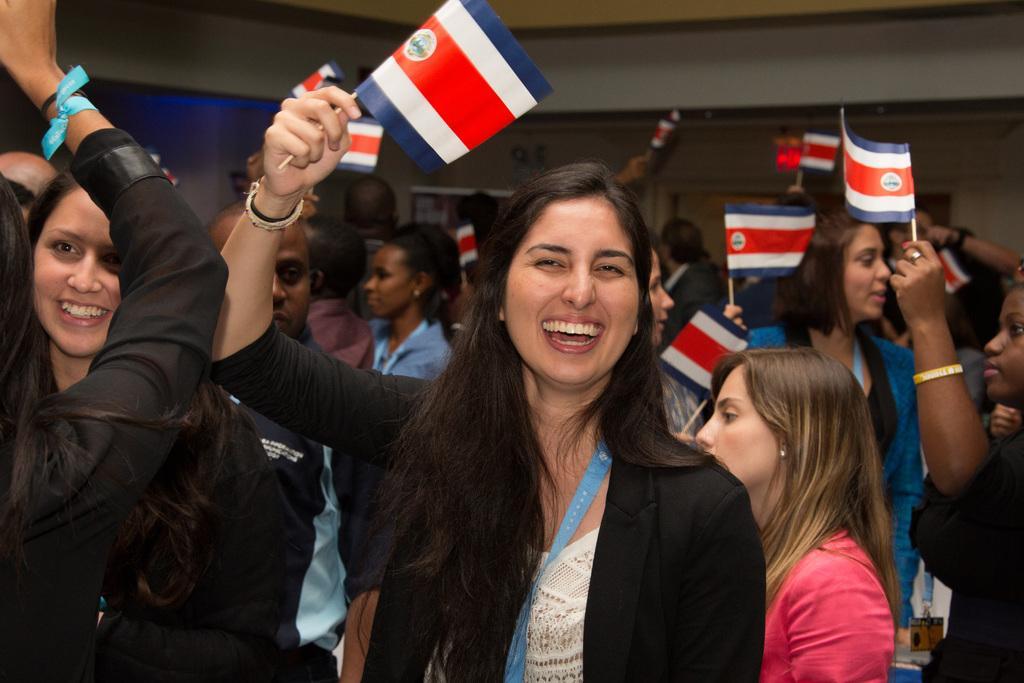Please provide a concise description of this image. Here we can see group of people. They are smiling and they are holding flags with their hands. In the background we can see wall. 